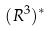Convert formula to latex. <formula><loc_0><loc_0><loc_500><loc_500>( R ^ { 3 } ) ^ { * }</formula> 